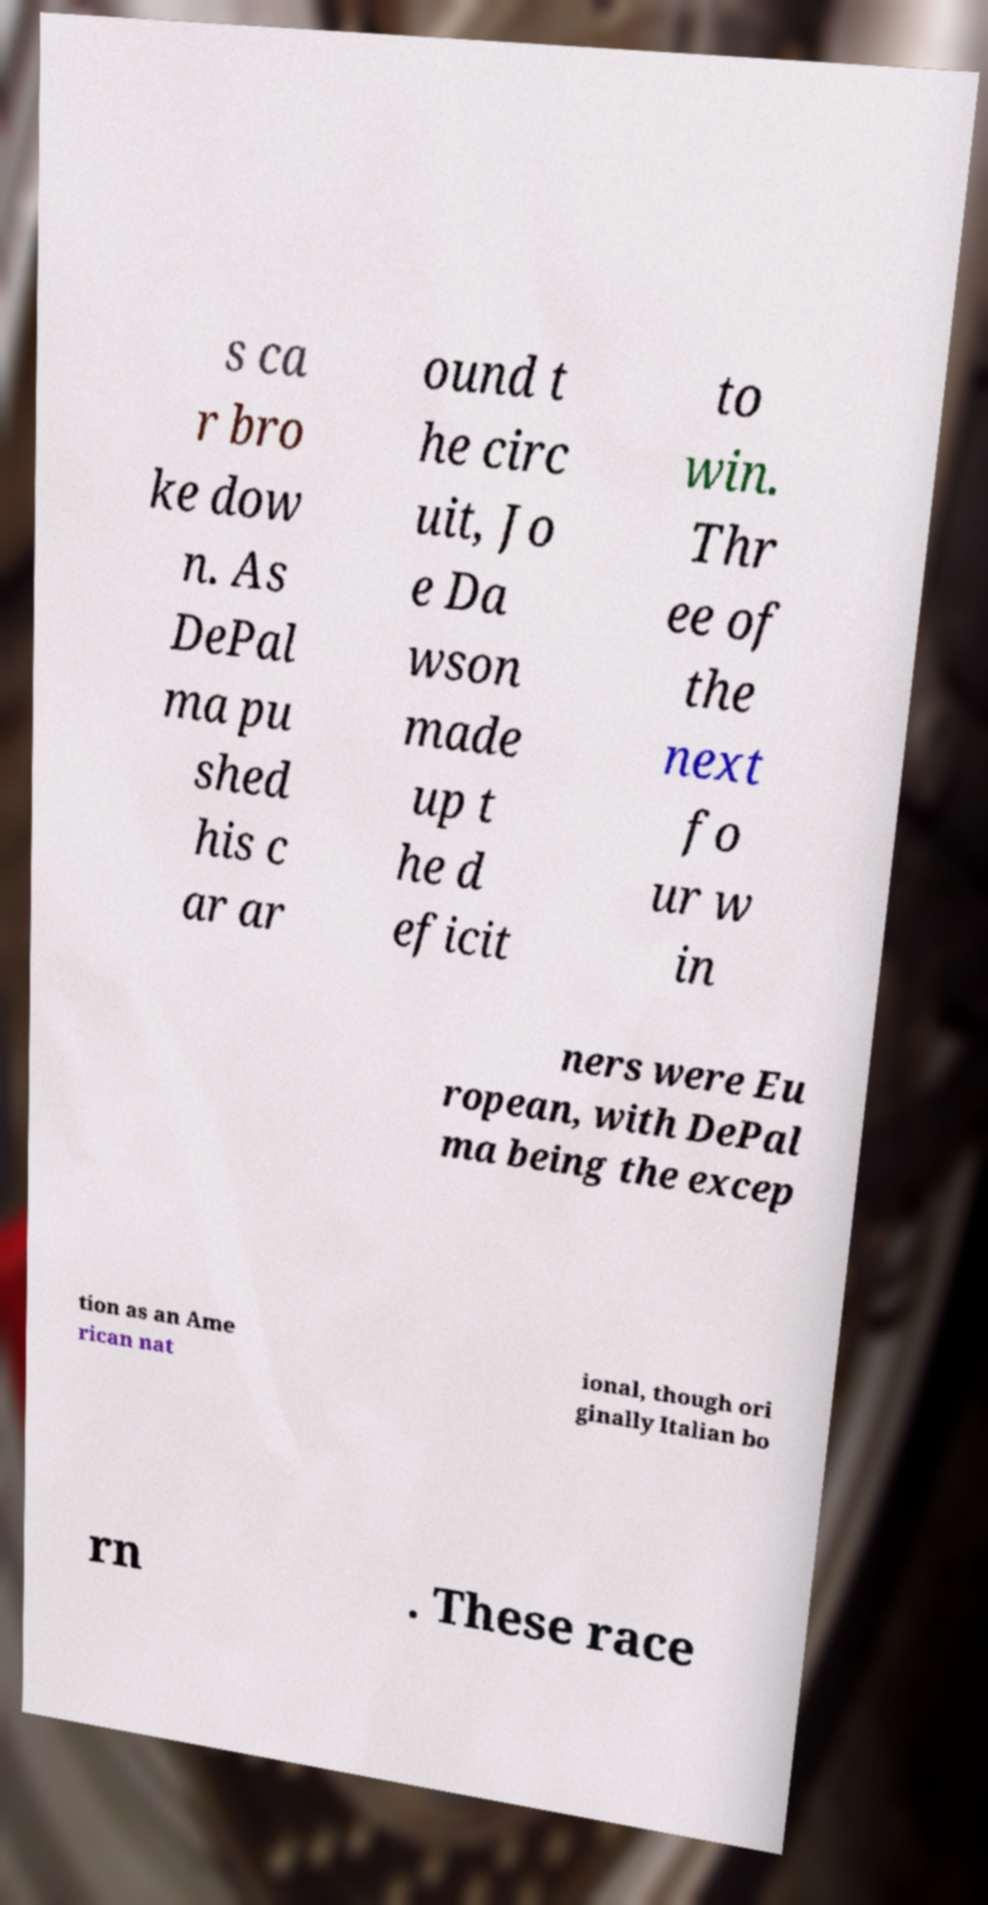Could you assist in decoding the text presented in this image and type it out clearly? s ca r bro ke dow n. As DePal ma pu shed his c ar ar ound t he circ uit, Jo e Da wson made up t he d eficit to win. Thr ee of the next fo ur w in ners were Eu ropean, with DePal ma being the excep tion as an Ame rican nat ional, though ori ginally Italian bo rn . These race 